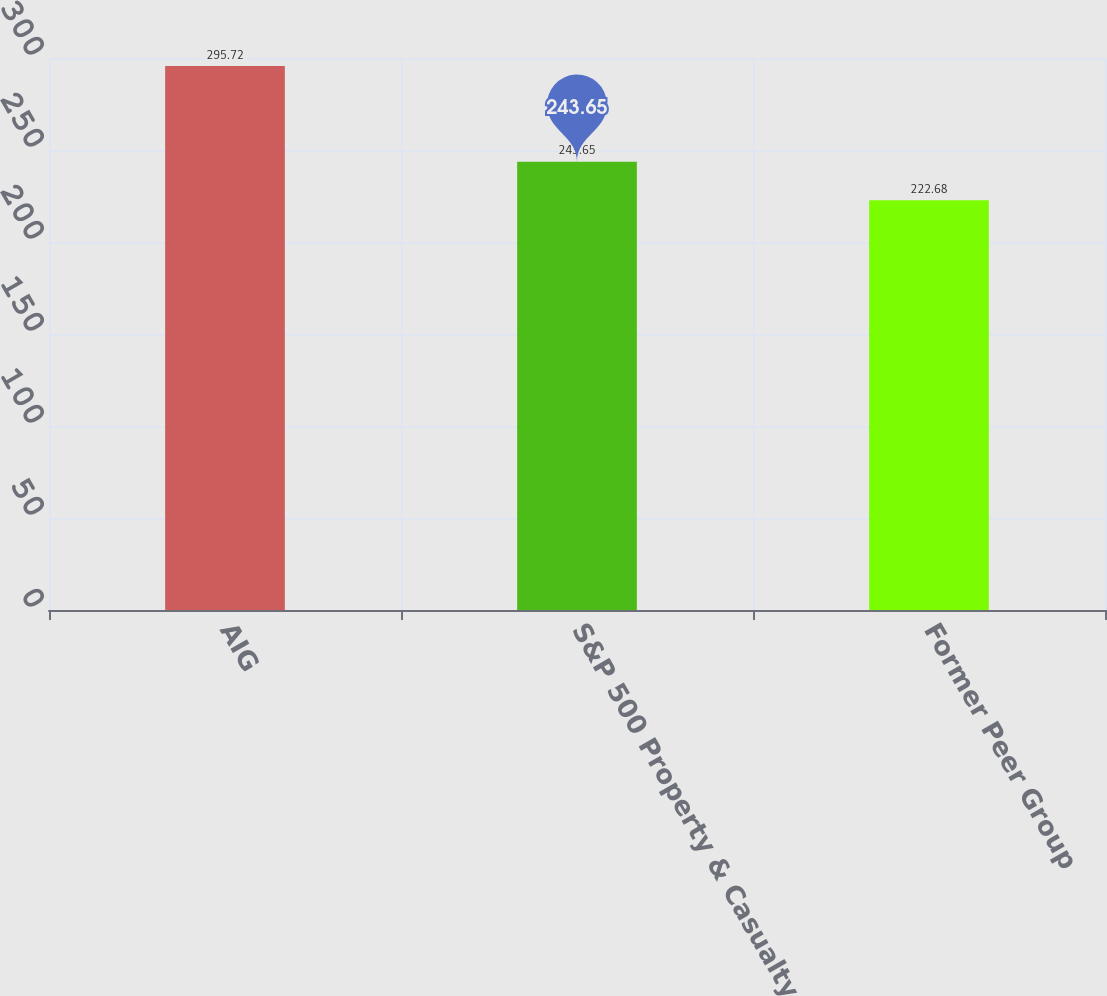<chart> <loc_0><loc_0><loc_500><loc_500><bar_chart><fcel>AIG<fcel>S&P 500 Property & Casualty<fcel>Former Peer Group<nl><fcel>295.72<fcel>243.65<fcel>222.68<nl></chart> 